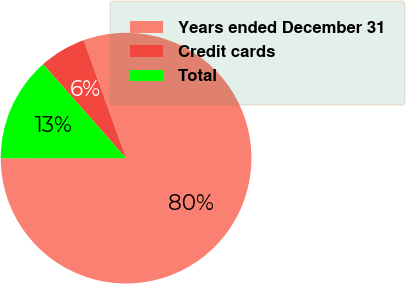<chart> <loc_0><loc_0><loc_500><loc_500><pie_chart><fcel>Years ended December 31<fcel>Credit cards<fcel>Total<nl><fcel>80.49%<fcel>6.03%<fcel>13.48%<nl></chart> 